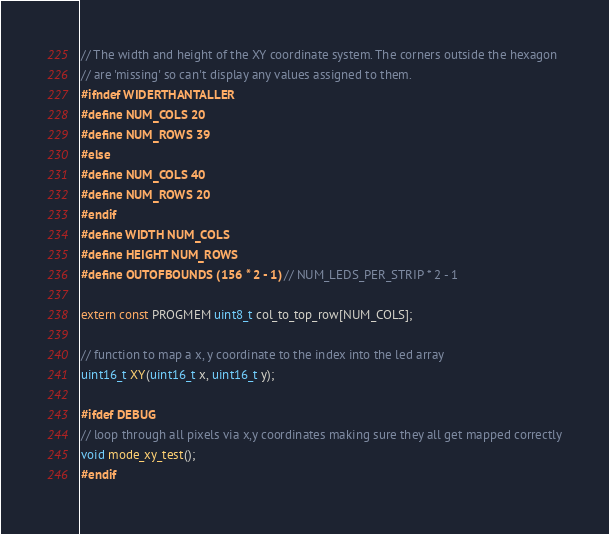Convert code to text. <code><loc_0><loc_0><loc_500><loc_500><_C_>// The width and height of the XY coordinate system. The corners outside the hexagon
// are 'missing' so can't display any values assigned to them.
#ifndef WIDERTHANTALLER
#define NUM_COLS 20
#define NUM_ROWS 39
#else
#define NUM_COLS 40
#define NUM_ROWS 20
#endif
#define WIDTH NUM_COLS
#define HEIGHT NUM_ROWS
#define OUTOFBOUNDS (156 * 2 - 1) // NUM_LEDS_PER_STRIP * 2 - 1

extern const PROGMEM uint8_t col_to_top_row[NUM_COLS];

// function to map a x, y coordinate to the index into the led array
uint16_t XY(uint16_t x, uint16_t y);

#ifdef DEBUG
// loop through all pixels via x,y coordinates making sure they all get mapped correctly
void mode_xy_test();
#endif
</code> 